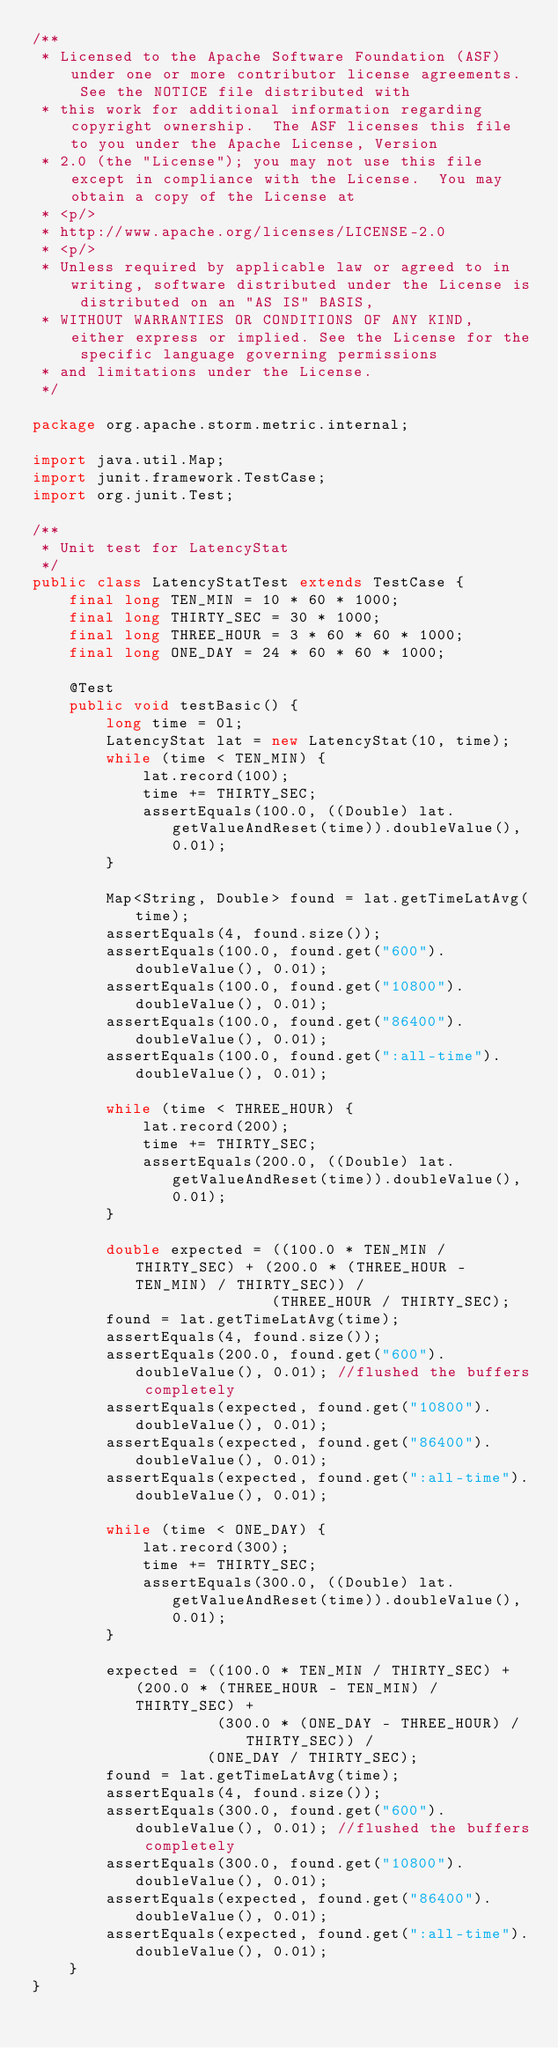Convert code to text. <code><loc_0><loc_0><loc_500><loc_500><_Java_>/**
 * Licensed to the Apache Software Foundation (ASF) under one or more contributor license agreements.  See the NOTICE file distributed with
 * this work for additional information regarding copyright ownership.  The ASF licenses this file to you under the Apache License, Version
 * 2.0 (the "License"); you may not use this file except in compliance with the License.  You may obtain a copy of the License at
 * <p/>
 * http://www.apache.org/licenses/LICENSE-2.0
 * <p/>
 * Unless required by applicable law or agreed to in writing, software distributed under the License is distributed on an "AS IS" BASIS,
 * WITHOUT WARRANTIES OR CONDITIONS OF ANY KIND, either express or implied. See the License for the specific language governing permissions
 * and limitations under the License.
 */

package org.apache.storm.metric.internal;

import java.util.Map;
import junit.framework.TestCase;
import org.junit.Test;

/**
 * Unit test for LatencyStat
 */
public class LatencyStatTest extends TestCase {
    final long TEN_MIN = 10 * 60 * 1000;
    final long THIRTY_SEC = 30 * 1000;
    final long THREE_HOUR = 3 * 60 * 60 * 1000;
    final long ONE_DAY = 24 * 60 * 60 * 1000;

    @Test
    public void testBasic() {
        long time = 0l;
        LatencyStat lat = new LatencyStat(10, time);
        while (time < TEN_MIN) {
            lat.record(100);
            time += THIRTY_SEC;
            assertEquals(100.0, ((Double) lat.getValueAndReset(time)).doubleValue(), 0.01);
        }

        Map<String, Double> found = lat.getTimeLatAvg(time);
        assertEquals(4, found.size());
        assertEquals(100.0, found.get("600").doubleValue(), 0.01);
        assertEquals(100.0, found.get("10800").doubleValue(), 0.01);
        assertEquals(100.0, found.get("86400").doubleValue(), 0.01);
        assertEquals(100.0, found.get(":all-time").doubleValue(), 0.01);

        while (time < THREE_HOUR) {
            lat.record(200);
            time += THIRTY_SEC;
            assertEquals(200.0, ((Double) lat.getValueAndReset(time)).doubleValue(), 0.01);
        }

        double expected = ((100.0 * TEN_MIN / THIRTY_SEC) + (200.0 * (THREE_HOUR - TEN_MIN) / THIRTY_SEC)) /
                          (THREE_HOUR / THIRTY_SEC);
        found = lat.getTimeLatAvg(time);
        assertEquals(4, found.size());
        assertEquals(200.0, found.get("600").doubleValue(), 0.01); //flushed the buffers completely
        assertEquals(expected, found.get("10800").doubleValue(), 0.01);
        assertEquals(expected, found.get("86400").doubleValue(), 0.01);
        assertEquals(expected, found.get(":all-time").doubleValue(), 0.01);

        while (time < ONE_DAY) {
            lat.record(300);
            time += THIRTY_SEC;
            assertEquals(300.0, ((Double) lat.getValueAndReset(time)).doubleValue(), 0.01);
        }

        expected = ((100.0 * TEN_MIN / THIRTY_SEC) + (200.0 * (THREE_HOUR - TEN_MIN) / THIRTY_SEC) +
                    (300.0 * (ONE_DAY - THREE_HOUR) / THIRTY_SEC)) /
                   (ONE_DAY / THIRTY_SEC);
        found = lat.getTimeLatAvg(time);
        assertEquals(4, found.size());
        assertEquals(300.0, found.get("600").doubleValue(), 0.01); //flushed the buffers completely
        assertEquals(300.0, found.get("10800").doubleValue(), 0.01);
        assertEquals(expected, found.get("86400").doubleValue(), 0.01);
        assertEquals(expected, found.get(":all-time").doubleValue(), 0.01);
    }
}
</code> 